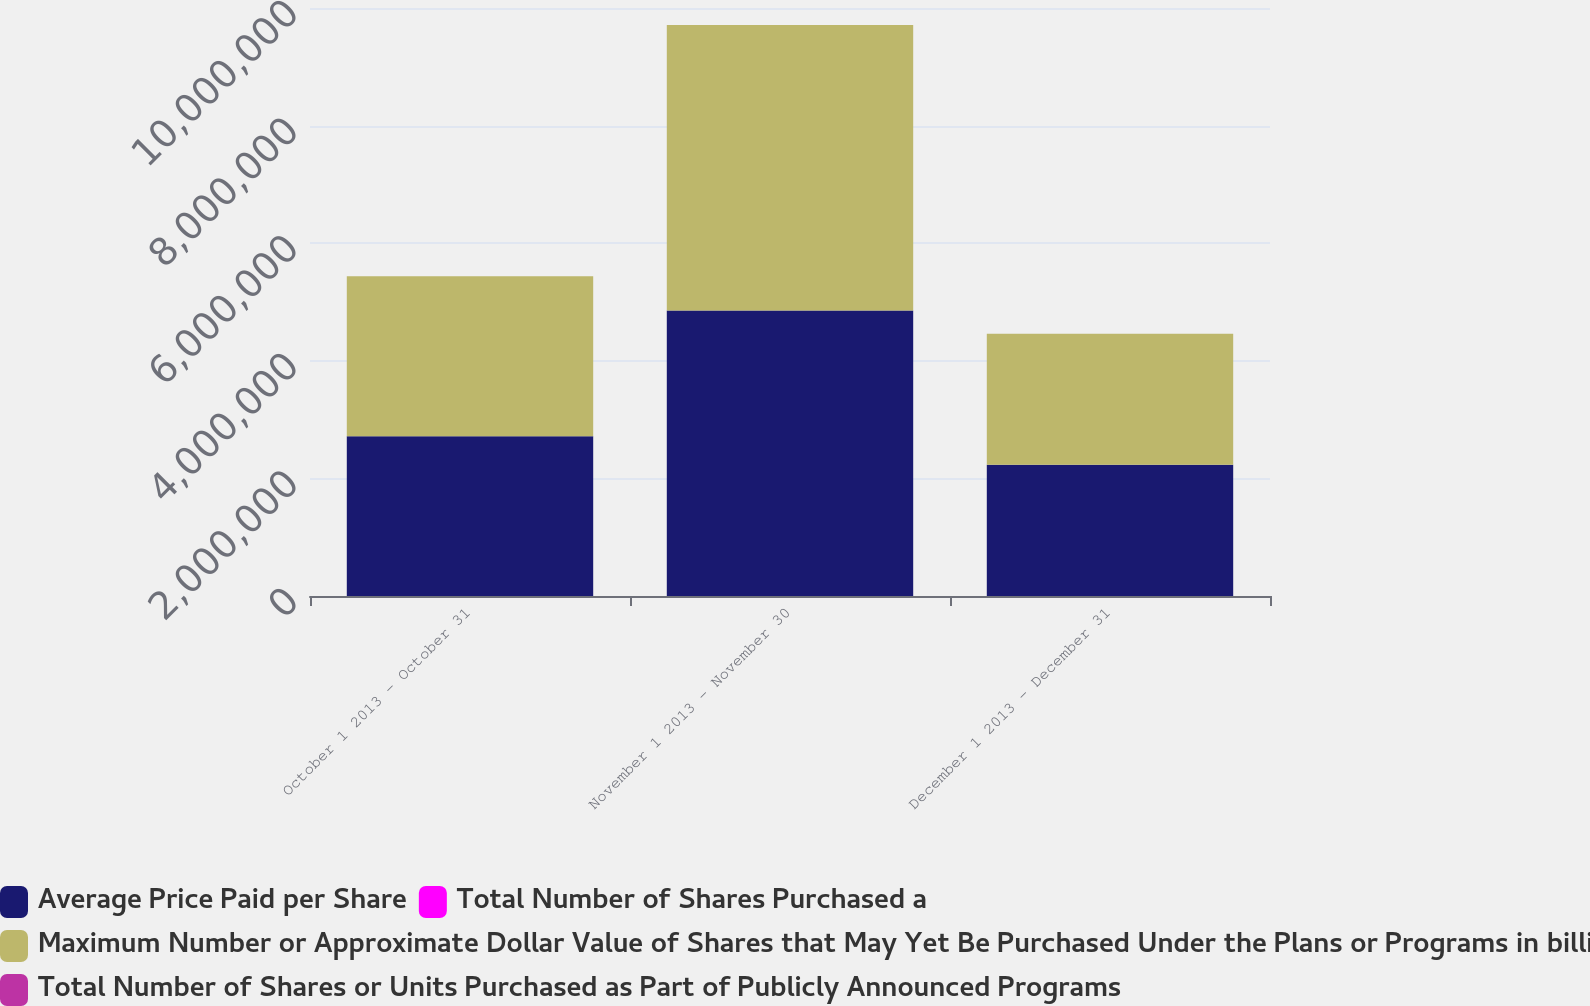Convert chart to OTSL. <chart><loc_0><loc_0><loc_500><loc_500><stacked_bar_chart><ecel><fcel>October 1 2013 - October 31<fcel>November 1 2013 - November 30<fcel>December 1 2013 - December 31<nl><fcel>Average Price Paid per Share<fcel>2.71847e+06<fcel>4.8559e+06<fcel>2.23021e+06<nl><fcel>Total Number of Shares Purchased a<fcel>44.54<fcel>44.67<fcel>46.93<nl><fcel>Maximum Number or Approximate Dollar Value of Shares that May Yet Be Purchased Under the Plans or Programs in billions<fcel>2.71798e+06<fcel>4.8559e+06<fcel>2.22853e+06<nl><fcel>Total Number of Shares or Units Purchased as Part of Publicly Announced Programs<fcel>1.36<fcel>1.14<fcel>1.04<nl></chart> 